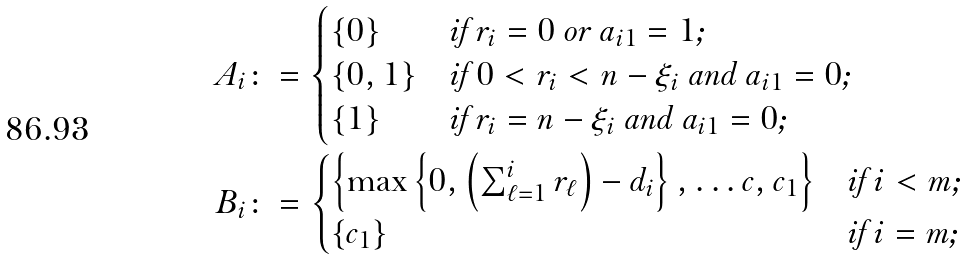<formula> <loc_0><loc_0><loc_500><loc_500>A _ { i } & \colon = \begin{cases} \{ 0 \} & \text {if $r_{i}=0$ or $a_{i1}=1$;} \\ \{ 0 , 1 \} & \text {if $0 < r_{i} < n-\xi_{i}$ and $a_{i1}=0$;} \\ \{ 1 \} & \text {if $r_{i}= n-\xi_{i}$ and $a_{i1}=0$;} \end{cases} \\ B _ { i } & \colon = \begin{cases} \left \{ \max \left \{ 0 , \left ( \sum _ { \ell = 1 } ^ { i } r _ { \ell } \right ) - d _ { i } \right \} , \dots c , c _ { 1 } \right \} & \text {if $i < m$;} \\ \{ c _ { 1 } \} & \text {if $i = m$;} \end{cases}</formula> 